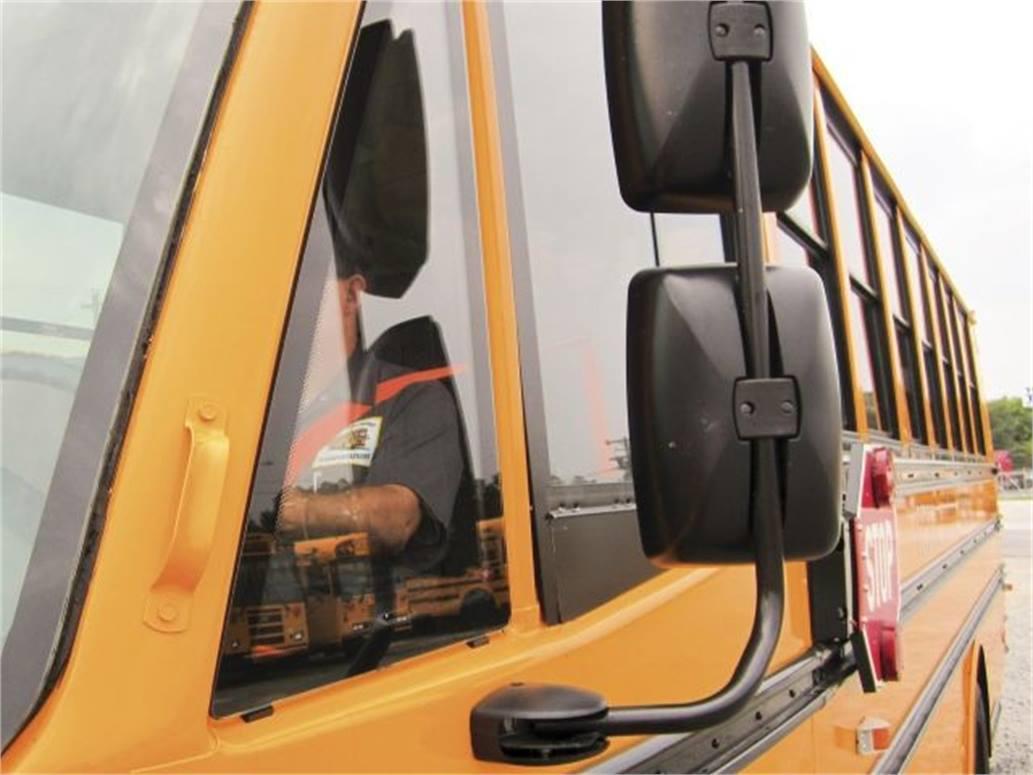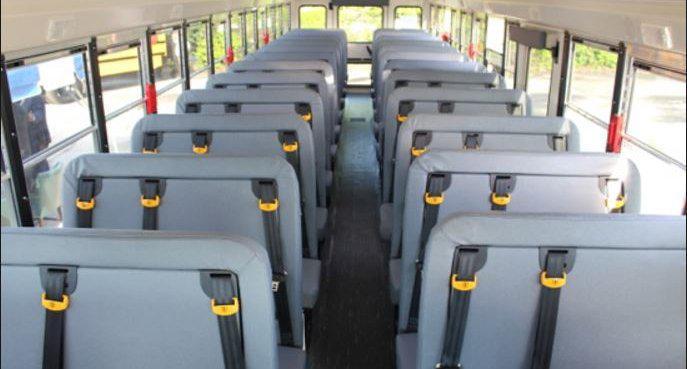The first image is the image on the left, the second image is the image on the right. Considering the images on both sides, is "In one of the images the steering wheel is visible." valid? Answer yes or no. No. The first image is the image on the left, the second image is the image on the right. Examine the images to the left and right. Is the description "One image shows a head-on view of the aisle inside a bus, which has grayish seats and black seatbelts with bright yellow locking mechanisms." accurate? Answer yes or no. Yes. 